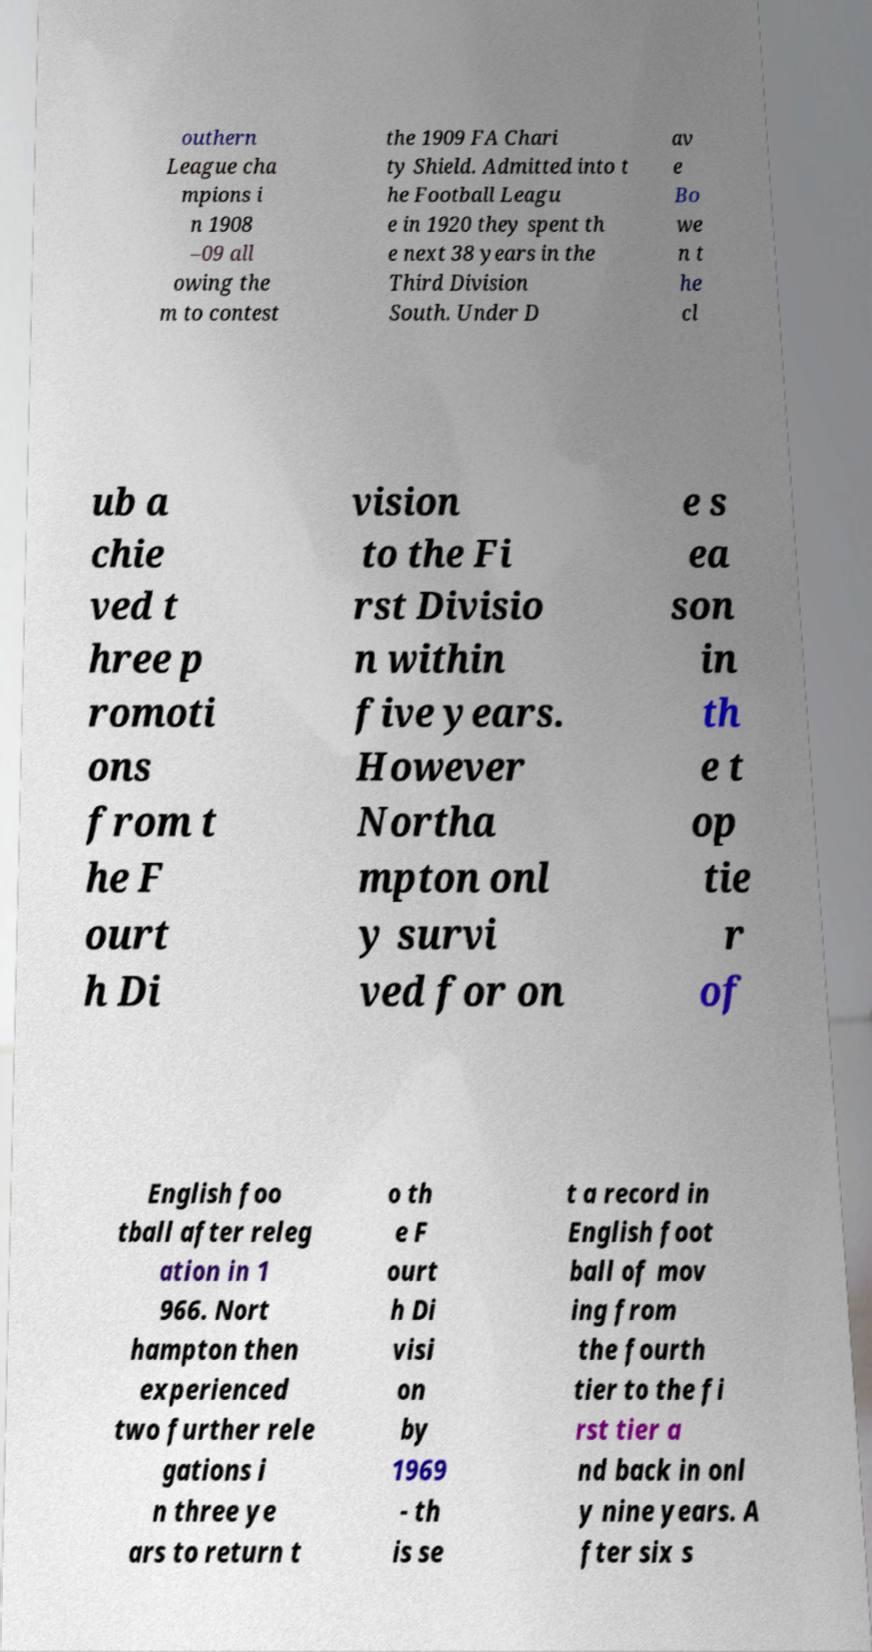For documentation purposes, I need the text within this image transcribed. Could you provide that? outhern League cha mpions i n 1908 –09 all owing the m to contest the 1909 FA Chari ty Shield. Admitted into t he Football Leagu e in 1920 they spent th e next 38 years in the Third Division South. Under D av e Bo we n t he cl ub a chie ved t hree p romoti ons from t he F ourt h Di vision to the Fi rst Divisio n within five years. However Northa mpton onl y survi ved for on e s ea son in th e t op tie r of English foo tball after releg ation in 1 966. Nort hampton then experienced two further rele gations i n three ye ars to return t o th e F ourt h Di visi on by 1969 - th is se t a record in English foot ball of mov ing from the fourth tier to the fi rst tier a nd back in onl y nine years. A fter six s 